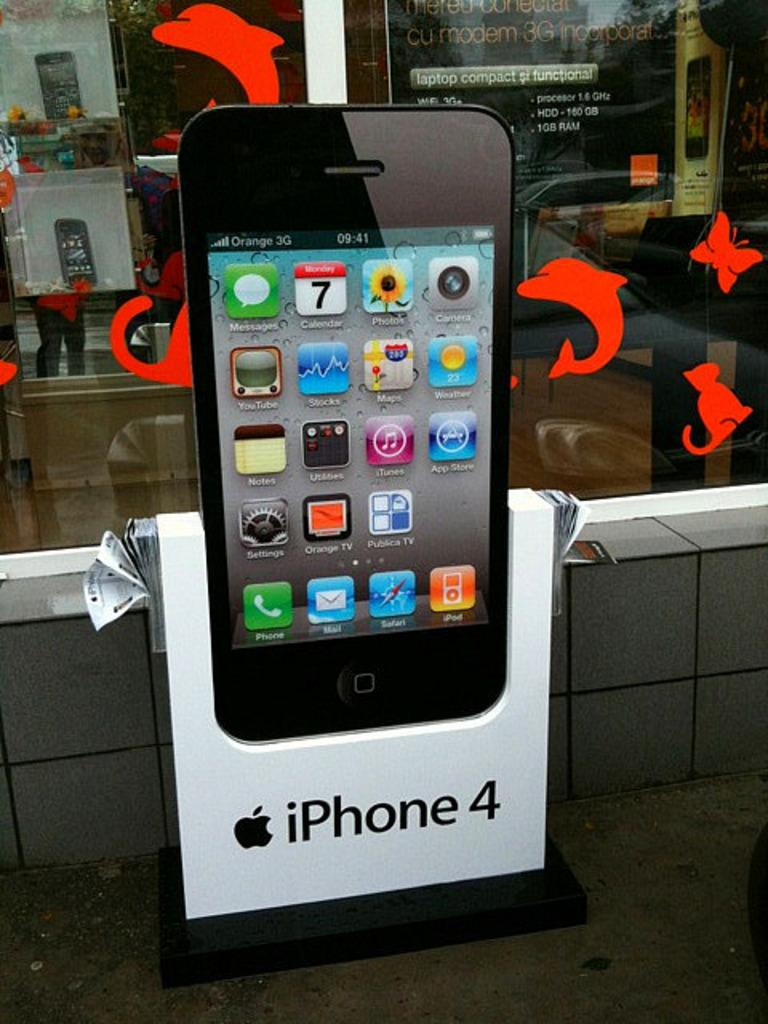Provide a one-sentence caption for the provided image. An iPhone 4 large model outside of a laptop computer store with flyers at the side. 